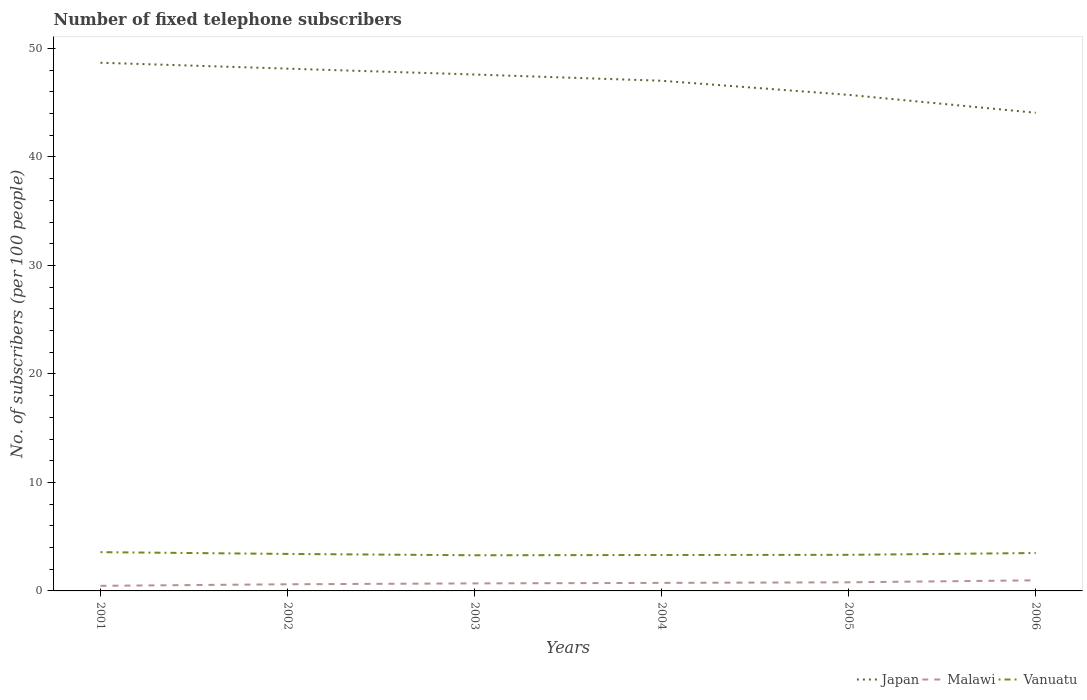How many different coloured lines are there?
Offer a terse response. 3. Does the line corresponding to Vanuatu intersect with the line corresponding to Malawi?
Give a very brief answer. No. Across all years, what is the maximum number of fixed telephone subscribers in Vanuatu?
Your response must be concise. 3.29. What is the total number of fixed telephone subscribers in Vanuatu in the graph?
Your answer should be very brief. 0.12. What is the difference between the highest and the second highest number of fixed telephone subscribers in Malawi?
Make the answer very short. 0.51. What is the difference between the highest and the lowest number of fixed telephone subscribers in Japan?
Offer a very short reply. 4. Is the number of fixed telephone subscribers in Malawi strictly greater than the number of fixed telephone subscribers in Japan over the years?
Your response must be concise. Yes. How many lines are there?
Your answer should be compact. 3. How many years are there in the graph?
Give a very brief answer. 6. Are the values on the major ticks of Y-axis written in scientific E-notation?
Offer a terse response. No. Does the graph contain grids?
Offer a terse response. No. How many legend labels are there?
Give a very brief answer. 3. How are the legend labels stacked?
Offer a terse response. Horizontal. What is the title of the graph?
Ensure brevity in your answer.  Number of fixed telephone subscribers. Does "Yemen, Rep." appear as one of the legend labels in the graph?
Give a very brief answer. No. What is the label or title of the X-axis?
Offer a terse response. Years. What is the label or title of the Y-axis?
Ensure brevity in your answer.  No. of subscribers (per 100 people). What is the No. of subscribers (per 100 people) of Japan in 2001?
Your answer should be compact. 48.68. What is the No. of subscribers (per 100 people) in Malawi in 2001?
Your answer should be very brief. 0.47. What is the No. of subscribers (per 100 people) of Vanuatu in 2001?
Ensure brevity in your answer.  3.57. What is the No. of subscribers (per 100 people) in Japan in 2002?
Your response must be concise. 48.14. What is the No. of subscribers (per 100 people) of Malawi in 2002?
Provide a short and direct response. 0.61. What is the No. of subscribers (per 100 people) in Vanuatu in 2002?
Provide a short and direct response. 3.41. What is the No. of subscribers (per 100 people) of Japan in 2003?
Your answer should be very brief. 47.6. What is the No. of subscribers (per 100 people) of Malawi in 2003?
Offer a very short reply. 0.69. What is the No. of subscribers (per 100 people) of Vanuatu in 2003?
Offer a terse response. 3.29. What is the No. of subscribers (per 100 people) of Japan in 2004?
Your response must be concise. 47.02. What is the No. of subscribers (per 100 people) of Malawi in 2004?
Give a very brief answer. 0.74. What is the No. of subscribers (per 100 people) of Vanuatu in 2004?
Offer a terse response. 3.31. What is the No. of subscribers (per 100 people) in Japan in 2005?
Your response must be concise. 45.72. What is the No. of subscribers (per 100 people) in Malawi in 2005?
Provide a succinct answer. 0.79. What is the No. of subscribers (per 100 people) of Vanuatu in 2005?
Offer a very short reply. 3.33. What is the No. of subscribers (per 100 people) in Japan in 2006?
Offer a terse response. 44.07. What is the No. of subscribers (per 100 people) of Malawi in 2006?
Provide a succinct answer. 0.98. What is the No. of subscribers (per 100 people) in Vanuatu in 2006?
Keep it short and to the point. 3.49. Across all years, what is the maximum No. of subscribers (per 100 people) of Japan?
Offer a terse response. 48.68. Across all years, what is the maximum No. of subscribers (per 100 people) of Malawi?
Offer a terse response. 0.98. Across all years, what is the maximum No. of subscribers (per 100 people) of Vanuatu?
Your response must be concise. 3.57. Across all years, what is the minimum No. of subscribers (per 100 people) of Japan?
Offer a terse response. 44.07. Across all years, what is the minimum No. of subscribers (per 100 people) in Malawi?
Give a very brief answer. 0.47. Across all years, what is the minimum No. of subscribers (per 100 people) of Vanuatu?
Offer a very short reply. 3.29. What is the total No. of subscribers (per 100 people) of Japan in the graph?
Your answer should be very brief. 281.22. What is the total No. of subscribers (per 100 people) in Malawi in the graph?
Your answer should be compact. 4.29. What is the total No. of subscribers (per 100 people) in Vanuatu in the graph?
Give a very brief answer. 20.4. What is the difference between the No. of subscribers (per 100 people) in Japan in 2001 and that in 2002?
Give a very brief answer. 0.54. What is the difference between the No. of subscribers (per 100 people) of Malawi in 2001 and that in 2002?
Offer a terse response. -0.14. What is the difference between the No. of subscribers (per 100 people) in Vanuatu in 2001 and that in 2002?
Give a very brief answer. 0.16. What is the difference between the No. of subscribers (per 100 people) of Japan in 2001 and that in 2003?
Provide a succinct answer. 1.09. What is the difference between the No. of subscribers (per 100 people) of Malawi in 2001 and that in 2003?
Provide a succinct answer. -0.22. What is the difference between the No. of subscribers (per 100 people) of Vanuatu in 2001 and that in 2003?
Provide a succinct answer. 0.29. What is the difference between the No. of subscribers (per 100 people) of Japan in 2001 and that in 2004?
Offer a very short reply. 1.66. What is the difference between the No. of subscribers (per 100 people) of Malawi in 2001 and that in 2004?
Make the answer very short. -0.27. What is the difference between the No. of subscribers (per 100 people) of Vanuatu in 2001 and that in 2004?
Offer a very short reply. 0.26. What is the difference between the No. of subscribers (per 100 people) in Japan in 2001 and that in 2005?
Your response must be concise. 2.96. What is the difference between the No. of subscribers (per 100 people) in Malawi in 2001 and that in 2005?
Your answer should be very brief. -0.33. What is the difference between the No. of subscribers (per 100 people) of Vanuatu in 2001 and that in 2005?
Offer a terse response. 0.25. What is the difference between the No. of subscribers (per 100 people) of Japan in 2001 and that in 2006?
Ensure brevity in your answer.  4.61. What is the difference between the No. of subscribers (per 100 people) of Malawi in 2001 and that in 2006?
Offer a very short reply. -0.51. What is the difference between the No. of subscribers (per 100 people) of Vanuatu in 2001 and that in 2006?
Provide a succinct answer. 0.08. What is the difference between the No. of subscribers (per 100 people) of Japan in 2002 and that in 2003?
Ensure brevity in your answer.  0.54. What is the difference between the No. of subscribers (per 100 people) in Malawi in 2002 and that in 2003?
Keep it short and to the point. -0.08. What is the difference between the No. of subscribers (per 100 people) in Vanuatu in 2002 and that in 2003?
Offer a terse response. 0.12. What is the difference between the No. of subscribers (per 100 people) in Japan in 2002 and that in 2004?
Ensure brevity in your answer.  1.12. What is the difference between the No. of subscribers (per 100 people) in Malawi in 2002 and that in 2004?
Provide a short and direct response. -0.13. What is the difference between the No. of subscribers (per 100 people) of Vanuatu in 2002 and that in 2004?
Offer a terse response. 0.1. What is the difference between the No. of subscribers (per 100 people) of Japan in 2002 and that in 2005?
Provide a short and direct response. 2.42. What is the difference between the No. of subscribers (per 100 people) in Malawi in 2002 and that in 2005?
Offer a very short reply. -0.18. What is the difference between the No. of subscribers (per 100 people) in Vanuatu in 2002 and that in 2005?
Your response must be concise. 0.08. What is the difference between the No. of subscribers (per 100 people) in Japan in 2002 and that in 2006?
Offer a terse response. 4.07. What is the difference between the No. of subscribers (per 100 people) of Malawi in 2002 and that in 2006?
Ensure brevity in your answer.  -0.36. What is the difference between the No. of subscribers (per 100 people) in Vanuatu in 2002 and that in 2006?
Ensure brevity in your answer.  -0.09. What is the difference between the No. of subscribers (per 100 people) in Japan in 2003 and that in 2004?
Keep it short and to the point. 0.58. What is the difference between the No. of subscribers (per 100 people) of Malawi in 2003 and that in 2004?
Your response must be concise. -0.05. What is the difference between the No. of subscribers (per 100 people) in Vanuatu in 2003 and that in 2004?
Keep it short and to the point. -0.02. What is the difference between the No. of subscribers (per 100 people) in Japan in 2003 and that in 2005?
Your answer should be very brief. 1.88. What is the difference between the No. of subscribers (per 100 people) of Malawi in 2003 and that in 2005?
Your response must be concise. -0.1. What is the difference between the No. of subscribers (per 100 people) of Vanuatu in 2003 and that in 2005?
Provide a short and direct response. -0.04. What is the difference between the No. of subscribers (per 100 people) in Japan in 2003 and that in 2006?
Make the answer very short. 3.52. What is the difference between the No. of subscribers (per 100 people) in Malawi in 2003 and that in 2006?
Your response must be concise. -0.28. What is the difference between the No. of subscribers (per 100 people) of Vanuatu in 2003 and that in 2006?
Offer a very short reply. -0.21. What is the difference between the No. of subscribers (per 100 people) in Japan in 2004 and that in 2005?
Your answer should be very brief. 1.3. What is the difference between the No. of subscribers (per 100 people) in Malawi in 2004 and that in 2005?
Make the answer very short. -0.05. What is the difference between the No. of subscribers (per 100 people) of Vanuatu in 2004 and that in 2005?
Your answer should be very brief. -0.01. What is the difference between the No. of subscribers (per 100 people) in Japan in 2004 and that in 2006?
Ensure brevity in your answer.  2.95. What is the difference between the No. of subscribers (per 100 people) of Malawi in 2004 and that in 2006?
Provide a succinct answer. -0.24. What is the difference between the No. of subscribers (per 100 people) of Vanuatu in 2004 and that in 2006?
Offer a terse response. -0.18. What is the difference between the No. of subscribers (per 100 people) of Japan in 2005 and that in 2006?
Ensure brevity in your answer.  1.65. What is the difference between the No. of subscribers (per 100 people) in Malawi in 2005 and that in 2006?
Offer a terse response. -0.18. What is the difference between the No. of subscribers (per 100 people) of Vanuatu in 2005 and that in 2006?
Make the answer very short. -0.17. What is the difference between the No. of subscribers (per 100 people) in Japan in 2001 and the No. of subscribers (per 100 people) in Malawi in 2002?
Provide a short and direct response. 48.07. What is the difference between the No. of subscribers (per 100 people) in Japan in 2001 and the No. of subscribers (per 100 people) in Vanuatu in 2002?
Offer a very short reply. 45.27. What is the difference between the No. of subscribers (per 100 people) of Malawi in 2001 and the No. of subscribers (per 100 people) of Vanuatu in 2002?
Give a very brief answer. -2.94. What is the difference between the No. of subscribers (per 100 people) in Japan in 2001 and the No. of subscribers (per 100 people) in Malawi in 2003?
Your answer should be very brief. 47.99. What is the difference between the No. of subscribers (per 100 people) in Japan in 2001 and the No. of subscribers (per 100 people) in Vanuatu in 2003?
Give a very brief answer. 45.39. What is the difference between the No. of subscribers (per 100 people) of Malawi in 2001 and the No. of subscribers (per 100 people) of Vanuatu in 2003?
Ensure brevity in your answer.  -2.82. What is the difference between the No. of subscribers (per 100 people) of Japan in 2001 and the No. of subscribers (per 100 people) of Malawi in 2004?
Make the answer very short. 47.94. What is the difference between the No. of subscribers (per 100 people) of Japan in 2001 and the No. of subscribers (per 100 people) of Vanuatu in 2004?
Keep it short and to the point. 45.37. What is the difference between the No. of subscribers (per 100 people) of Malawi in 2001 and the No. of subscribers (per 100 people) of Vanuatu in 2004?
Give a very brief answer. -2.84. What is the difference between the No. of subscribers (per 100 people) in Japan in 2001 and the No. of subscribers (per 100 people) in Malawi in 2005?
Offer a very short reply. 47.89. What is the difference between the No. of subscribers (per 100 people) in Japan in 2001 and the No. of subscribers (per 100 people) in Vanuatu in 2005?
Your answer should be compact. 45.36. What is the difference between the No. of subscribers (per 100 people) in Malawi in 2001 and the No. of subscribers (per 100 people) in Vanuatu in 2005?
Offer a very short reply. -2.86. What is the difference between the No. of subscribers (per 100 people) in Japan in 2001 and the No. of subscribers (per 100 people) in Malawi in 2006?
Offer a very short reply. 47.7. What is the difference between the No. of subscribers (per 100 people) of Japan in 2001 and the No. of subscribers (per 100 people) of Vanuatu in 2006?
Offer a terse response. 45.19. What is the difference between the No. of subscribers (per 100 people) in Malawi in 2001 and the No. of subscribers (per 100 people) in Vanuatu in 2006?
Provide a short and direct response. -3.02. What is the difference between the No. of subscribers (per 100 people) in Japan in 2002 and the No. of subscribers (per 100 people) in Malawi in 2003?
Ensure brevity in your answer.  47.44. What is the difference between the No. of subscribers (per 100 people) in Japan in 2002 and the No. of subscribers (per 100 people) in Vanuatu in 2003?
Provide a short and direct response. 44.85. What is the difference between the No. of subscribers (per 100 people) in Malawi in 2002 and the No. of subscribers (per 100 people) in Vanuatu in 2003?
Keep it short and to the point. -2.67. What is the difference between the No. of subscribers (per 100 people) in Japan in 2002 and the No. of subscribers (per 100 people) in Malawi in 2004?
Provide a short and direct response. 47.4. What is the difference between the No. of subscribers (per 100 people) of Japan in 2002 and the No. of subscribers (per 100 people) of Vanuatu in 2004?
Your answer should be compact. 44.83. What is the difference between the No. of subscribers (per 100 people) in Malawi in 2002 and the No. of subscribers (per 100 people) in Vanuatu in 2004?
Make the answer very short. -2.7. What is the difference between the No. of subscribers (per 100 people) in Japan in 2002 and the No. of subscribers (per 100 people) in Malawi in 2005?
Your response must be concise. 47.34. What is the difference between the No. of subscribers (per 100 people) of Japan in 2002 and the No. of subscribers (per 100 people) of Vanuatu in 2005?
Offer a terse response. 44.81. What is the difference between the No. of subscribers (per 100 people) in Malawi in 2002 and the No. of subscribers (per 100 people) in Vanuatu in 2005?
Provide a succinct answer. -2.71. What is the difference between the No. of subscribers (per 100 people) in Japan in 2002 and the No. of subscribers (per 100 people) in Malawi in 2006?
Your answer should be very brief. 47.16. What is the difference between the No. of subscribers (per 100 people) in Japan in 2002 and the No. of subscribers (per 100 people) in Vanuatu in 2006?
Your answer should be compact. 44.64. What is the difference between the No. of subscribers (per 100 people) of Malawi in 2002 and the No. of subscribers (per 100 people) of Vanuatu in 2006?
Your answer should be compact. -2.88. What is the difference between the No. of subscribers (per 100 people) in Japan in 2003 and the No. of subscribers (per 100 people) in Malawi in 2004?
Your response must be concise. 46.86. What is the difference between the No. of subscribers (per 100 people) in Japan in 2003 and the No. of subscribers (per 100 people) in Vanuatu in 2004?
Keep it short and to the point. 44.28. What is the difference between the No. of subscribers (per 100 people) in Malawi in 2003 and the No. of subscribers (per 100 people) in Vanuatu in 2004?
Ensure brevity in your answer.  -2.62. What is the difference between the No. of subscribers (per 100 people) of Japan in 2003 and the No. of subscribers (per 100 people) of Malawi in 2005?
Your answer should be compact. 46.8. What is the difference between the No. of subscribers (per 100 people) in Japan in 2003 and the No. of subscribers (per 100 people) in Vanuatu in 2005?
Your answer should be compact. 44.27. What is the difference between the No. of subscribers (per 100 people) of Malawi in 2003 and the No. of subscribers (per 100 people) of Vanuatu in 2005?
Keep it short and to the point. -2.63. What is the difference between the No. of subscribers (per 100 people) in Japan in 2003 and the No. of subscribers (per 100 people) in Malawi in 2006?
Provide a succinct answer. 46.62. What is the difference between the No. of subscribers (per 100 people) in Japan in 2003 and the No. of subscribers (per 100 people) in Vanuatu in 2006?
Your response must be concise. 44.1. What is the difference between the No. of subscribers (per 100 people) in Malawi in 2003 and the No. of subscribers (per 100 people) in Vanuatu in 2006?
Provide a short and direct response. -2.8. What is the difference between the No. of subscribers (per 100 people) in Japan in 2004 and the No. of subscribers (per 100 people) in Malawi in 2005?
Your answer should be compact. 46.22. What is the difference between the No. of subscribers (per 100 people) in Japan in 2004 and the No. of subscribers (per 100 people) in Vanuatu in 2005?
Your answer should be very brief. 43.69. What is the difference between the No. of subscribers (per 100 people) in Malawi in 2004 and the No. of subscribers (per 100 people) in Vanuatu in 2005?
Your answer should be compact. -2.59. What is the difference between the No. of subscribers (per 100 people) in Japan in 2004 and the No. of subscribers (per 100 people) in Malawi in 2006?
Your answer should be compact. 46.04. What is the difference between the No. of subscribers (per 100 people) in Japan in 2004 and the No. of subscribers (per 100 people) in Vanuatu in 2006?
Offer a terse response. 43.53. What is the difference between the No. of subscribers (per 100 people) in Malawi in 2004 and the No. of subscribers (per 100 people) in Vanuatu in 2006?
Provide a short and direct response. -2.75. What is the difference between the No. of subscribers (per 100 people) of Japan in 2005 and the No. of subscribers (per 100 people) of Malawi in 2006?
Offer a very short reply. 44.74. What is the difference between the No. of subscribers (per 100 people) of Japan in 2005 and the No. of subscribers (per 100 people) of Vanuatu in 2006?
Give a very brief answer. 42.22. What is the difference between the No. of subscribers (per 100 people) in Malawi in 2005 and the No. of subscribers (per 100 people) in Vanuatu in 2006?
Your answer should be compact. -2.7. What is the average No. of subscribers (per 100 people) in Japan per year?
Make the answer very short. 46.87. What is the average No. of subscribers (per 100 people) in Malawi per year?
Provide a succinct answer. 0.71. What is the average No. of subscribers (per 100 people) in Vanuatu per year?
Make the answer very short. 3.4. In the year 2001, what is the difference between the No. of subscribers (per 100 people) in Japan and No. of subscribers (per 100 people) in Malawi?
Provide a succinct answer. 48.21. In the year 2001, what is the difference between the No. of subscribers (per 100 people) of Japan and No. of subscribers (per 100 people) of Vanuatu?
Your response must be concise. 45.11. In the year 2001, what is the difference between the No. of subscribers (per 100 people) in Malawi and No. of subscribers (per 100 people) in Vanuatu?
Provide a short and direct response. -3.1. In the year 2002, what is the difference between the No. of subscribers (per 100 people) of Japan and No. of subscribers (per 100 people) of Malawi?
Provide a succinct answer. 47.52. In the year 2002, what is the difference between the No. of subscribers (per 100 people) in Japan and No. of subscribers (per 100 people) in Vanuatu?
Keep it short and to the point. 44.73. In the year 2002, what is the difference between the No. of subscribers (per 100 people) of Malawi and No. of subscribers (per 100 people) of Vanuatu?
Keep it short and to the point. -2.8. In the year 2003, what is the difference between the No. of subscribers (per 100 people) in Japan and No. of subscribers (per 100 people) in Malawi?
Provide a short and direct response. 46.9. In the year 2003, what is the difference between the No. of subscribers (per 100 people) of Japan and No. of subscribers (per 100 people) of Vanuatu?
Make the answer very short. 44.31. In the year 2003, what is the difference between the No. of subscribers (per 100 people) in Malawi and No. of subscribers (per 100 people) in Vanuatu?
Make the answer very short. -2.59. In the year 2004, what is the difference between the No. of subscribers (per 100 people) in Japan and No. of subscribers (per 100 people) in Malawi?
Give a very brief answer. 46.28. In the year 2004, what is the difference between the No. of subscribers (per 100 people) of Japan and No. of subscribers (per 100 people) of Vanuatu?
Your response must be concise. 43.71. In the year 2004, what is the difference between the No. of subscribers (per 100 people) in Malawi and No. of subscribers (per 100 people) in Vanuatu?
Ensure brevity in your answer.  -2.57. In the year 2005, what is the difference between the No. of subscribers (per 100 people) of Japan and No. of subscribers (per 100 people) of Malawi?
Your answer should be compact. 44.92. In the year 2005, what is the difference between the No. of subscribers (per 100 people) of Japan and No. of subscribers (per 100 people) of Vanuatu?
Make the answer very short. 42.39. In the year 2005, what is the difference between the No. of subscribers (per 100 people) of Malawi and No. of subscribers (per 100 people) of Vanuatu?
Provide a short and direct response. -2.53. In the year 2006, what is the difference between the No. of subscribers (per 100 people) of Japan and No. of subscribers (per 100 people) of Malawi?
Keep it short and to the point. 43.09. In the year 2006, what is the difference between the No. of subscribers (per 100 people) of Japan and No. of subscribers (per 100 people) of Vanuatu?
Provide a succinct answer. 40.58. In the year 2006, what is the difference between the No. of subscribers (per 100 people) of Malawi and No. of subscribers (per 100 people) of Vanuatu?
Your answer should be very brief. -2.52. What is the ratio of the No. of subscribers (per 100 people) in Japan in 2001 to that in 2002?
Keep it short and to the point. 1.01. What is the ratio of the No. of subscribers (per 100 people) in Malawi in 2001 to that in 2002?
Offer a very short reply. 0.77. What is the ratio of the No. of subscribers (per 100 people) of Vanuatu in 2001 to that in 2002?
Your answer should be compact. 1.05. What is the ratio of the No. of subscribers (per 100 people) in Japan in 2001 to that in 2003?
Make the answer very short. 1.02. What is the ratio of the No. of subscribers (per 100 people) in Malawi in 2001 to that in 2003?
Keep it short and to the point. 0.68. What is the ratio of the No. of subscribers (per 100 people) of Vanuatu in 2001 to that in 2003?
Give a very brief answer. 1.09. What is the ratio of the No. of subscribers (per 100 people) of Japan in 2001 to that in 2004?
Provide a short and direct response. 1.04. What is the ratio of the No. of subscribers (per 100 people) in Malawi in 2001 to that in 2004?
Ensure brevity in your answer.  0.64. What is the ratio of the No. of subscribers (per 100 people) in Vanuatu in 2001 to that in 2004?
Keep it short and to the point. 1.08. What is the ratio of the No. of subscribers (per 100 people) in Japan in 2001 to that in 2005?
Make the answer very short. 1.06. What is the ratio of the No. of subscribers (per 100 people) of Malawi in 2001 to that in 2005?
Your answer should be very brief. 0.59. What is the ratio of the No. of subscribers (per 100 people) of Vanuatu in 2001 to that in 2005?
Offer a very short reply. 1.07. What is the ratio of the No. of subscribers (per 100 people) of Japan in 2001 to that in 2006?
Make the answer very short. 1.1. What is the ratio of the No. of subscribers (per 100 people) in Malawi in 2001 to that in 2006?
Make the answer very short. 0.48. What is the ratio of the No. of subscribers (per 100 people) in Vanuatu in 2001 to that in 2006?
Your answer should be very brief. 1.02. What is the ratio of the No. of subscribers (per 100 people) in Japan in 2002 to that in 2003?
Your response must be concise. 1.01. What is the ratio of the No. of subscribers (per 100 people) of Malawi in 2002 to that in 2003?
Offer a terse response. 0.88. What is the ratio of the No. of subscribers (per 100 people) in Vanuatu in 2002 to that in 2003?
Provide a short and direct response. 1.04. What is the ratio of the No. of subscribers (per 100 people) of Japan in 2002 to that in 2004?
Provide a succinct answer. 1.02. What is the ratio of the No. of subscribers (per 100 people) of Malawi in 2002 to that in 2004?
Make the answer very short. 0.83. What is the ratio of the No. of subscribers (per 100 people) of Vanuatu in 2002 to that in 2004?
Make the answer very short. 1.03. What is the ratio of the No. of subscribers (per 100 people) of Japan in 2002 to that in 2005?
Ensure brevity in your answer.  1.05. What is the ratio of the No. of subscribers (per 100 people) of Malawi in 2002 to that in 2005?
Give a very brief answer. 0.77. What is the ratio of the No. of subscribers (per 100 people) of Vanuatu in 2002 to that in 2005?
Offer a terse response. 1.02. What is the ratio of the No. of subscribers (per 100 people) of Japan in 2002 to that in 2006?
Provide a short and direct response. 1.09. What is the ratio of the No. of subscribers (per 100 people) of Malawi in 2002 to that in 2006?
Keep it short and to the point. 0.63. What is the ratio of the No. of subscribers (per 100 people) in Vanuatu in 2002 to that in 2006?
Give a very brief answer. 0.98. What is the ratio of the No. of subscribers (per 100 people) in Japan in 2003 to that in 2004?
Offer a terse response. 1.01. What is the ratio of the No. of subscribers (per 100 people) of Malawi in 2003 to that in 2004?
Provide a succinct answer. 0.94. What is the ratio of the No. of subscribers (per 100 people) of Vanuatu in 2003 to that in 2004?
Offer a terse response. 0.99. What is the ratio of the No. of subscribers (per 100 people) of Japan in 2003 to that in 2005?
Your answer should be very brief. 1.04. What is the ratio of the No. of subscribers (per 100 people) of Malawi in 2003 to that in 2005?
Your response must be concise. 0.87. What is the ratio of the No. of subscribers (per 100 people) in Vanuatu in 2003 to that in 2005?
Give a very brief answer. 0.99. What is the ratio of the No. of subscribers (per 100 people) in Japan in 2003 to that in 2006?
Your response must be concise. 1.08. What is the ratio of the No. of subscribers (per 100 people) of Malawi in 2003 to that in 2006?
Your response must be concise. 0.71. What is the ratio of the No. of subscribers (per 100 people) of Vanuatu in 2003 to that in 2006?
Your answer should be compact. 0.94. What is the ratio of the No. of subscribers (per 100 people) in Japan in 2004 to that in 2005?
Your answer should be very brief. 1.03. What is the ratio of the No. of subscribers (per 100 people) in Malawi in 2004 to that in 2005?
Your answer should be very brief. 0.93. What is the ratio of the No. of subscribers (per 100 people) in Japan in 2004 to that in 2006?
Keep it short and to the point. 1.07. What is the ratio of the No. of subscribers (per 100 people) in Malawi in 2004 to that in 2006?
Your answer should be very brief. 0.76. What is the ratio of the No. of subscribers (per 100 people) in Vanuatu in 2004 to that in 2006?
Keep it short and to the point. 0.95. What is the ratio of the No. of subscribers (per 100 people) in Japan in 2005 to that in 2006?
Your response must be concise. 1.04. What is the ratio of the No. of subscribers (per 100 people) of Malawi in 2005 to that in 2006?
Provide a succinct answer. 0.81. What is the ratio of the No. of subscribers (per 100 people) of Vanuatu in 2005 to that in 2006?
Your response must be concise. 0.95. What is the difference between the highest and the second highest No. of subscribers (per 100 people) of Japan?
Your answer should be very brief. 0.54. What is the difference between the highest and the second highest No. of subscribers (per 100 people) of Malawi?
Your response must be concise. 0.18. What is the difference between the highest and the second highest No. of subscribers (per 100 people) in Vanuatu?
Provide a succinct answer. 0.08. What is the difference between the highest and the lowest No. of subscribers (per 100 people) of Japan?
Your response must be concise. 4.61. What is the difference between the highest and the lowest No. of subscribers (per 100 people) in Malawi?
Offer a terse response. 0.51. What is the difference between the highest and the lowest No. of subscribers (per 100 people) of Vanuatu?
Your response must be concise. 0.29. 